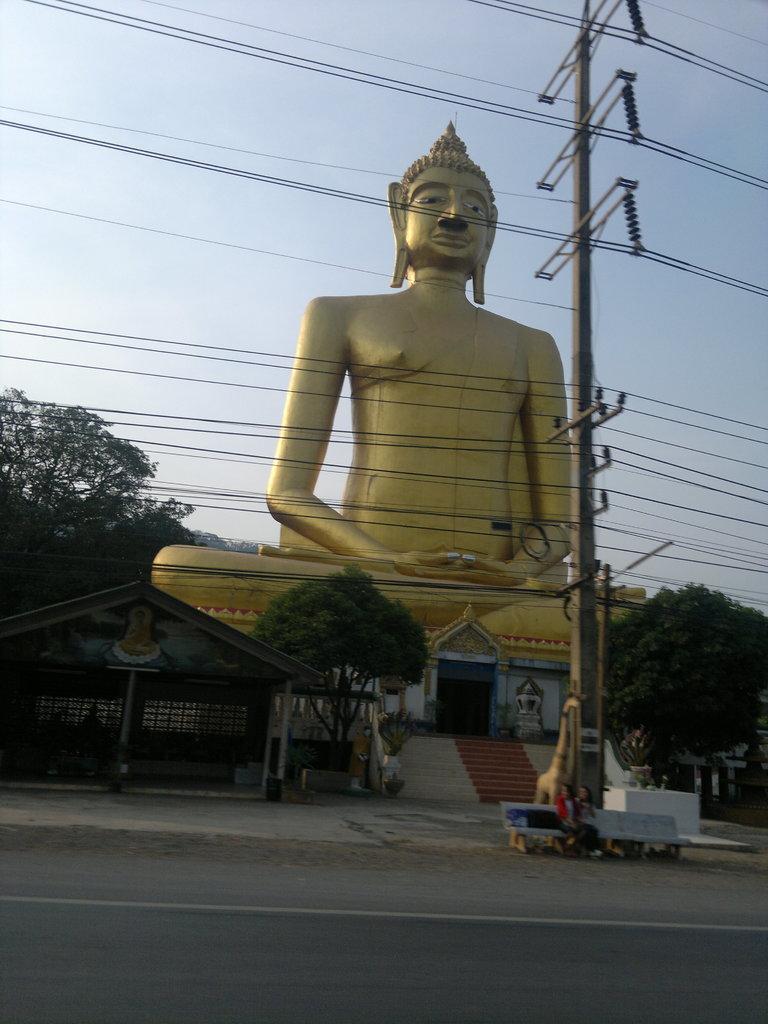In one or two sentences, can you explain what this image depicts? In the foreground, I can see two persons are sitting on a bench and I can see steps, trees, shed, fence and a door. In the background, I can see a statue of an idol, and I can see a pole, wires and the sky. This picture might be taken in a day. 